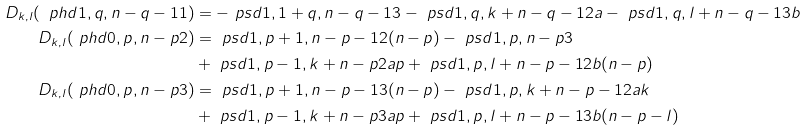Convert formula to latex. <formula><loc_0><loc_0><loc_500><loc_500>D _ { k , l } ( \ p h d { 1 , q , n - q - 1 } 1 ) & = - \ p s d { 1 , 1 + q , n - q - 1 } 3 - \ p s d { 1 , q , k + n - q - 1 } 2 a - \ p s d { 1 , q , l + n - q - 1 } 3 b \\ D _ { k , l } ( \ p h d { 0 , p , n - p } 2 ) & = \ p s d { 1 , p + 1 , n - p - 1 } 2 ( n - p ) - \ p s d { 1 , p , n - p } 3 \\ & + \ p s d { 1 , p - 1 , k + n - p } 2 a p + \ p s d { 1 , p , l + n - p - 1 } 2 b ( n - p ) \\ D _ { k , l } ( \ p h d { 0 , p , n - p } 3 ) & = \ p s d { 1 , p + 1 , n - p - 1 } 3 ( n - p ) - \ p s d { 1 , p , k + n - p - 1 } 2 a k \\ & + \ p s d { 1 , p - 1 , k + n - p } 3 a p + \ p s d { 1 , p , l + n - p - 1 } 3 b ( n - p - l )</formula> 